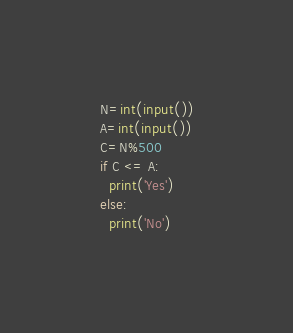<code> <loc_0><loc_0><loc_500><loc_500><_Python_>N=int(input())
A=int(input())
C=N%500
if C <= A:
  print('Yes')
else:
  print('No')</code> 